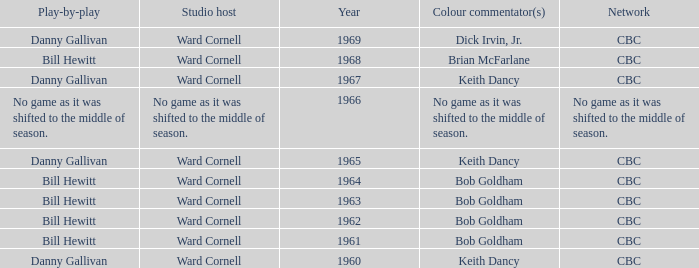Who did the play-by-play with studio host Ward Cornell and color commentator Bob Goldham? Bill Hewitt, Bill Hewitt, Bill Hewitt, Bill Hewitt. 